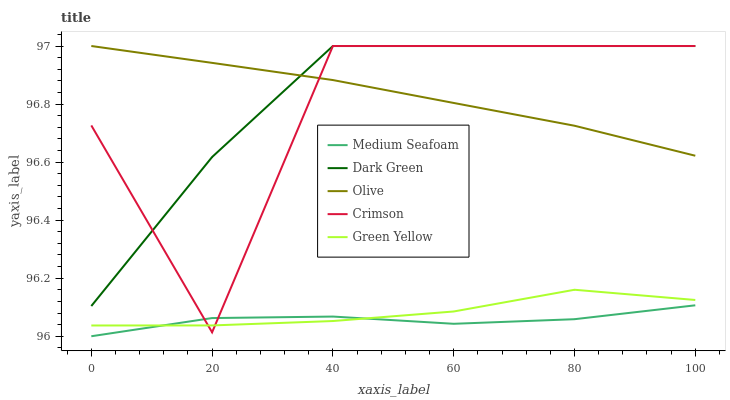Does Medium Seafoam have the minimum area under the curve?
Answer yes or no. Yes. Does Dark Green have the maximum area under the curve?
Answer yes or no. Yes. Does Crimson have the minimum area under the curve?
Answer yes or no. No. Does Crimson have the maximum area under the curve?
Answer yes or no. No. Is Olive the smoothest?
Answer yes or no. Yes. Is Crimson the roughest?
Answer yes or no. Yes. Is Green Yellow the smoothest?
Answer yes or no. No. Is Green Yellow the roughest?
Answer yes or no. No. Does Crimson have the lowest value?
Answer yes or no. No. Does Green Yellow have the highest value?
Answer yes or no. No. Is Medium Seafoam less than Dark Green?
Answer yes or no. Yes. Is Dark Green greater than Medium Seafoam?
Answer yes or no. Yes. Does Medium Seafoam intersect Dark Green?
Answer yes or no. No. 